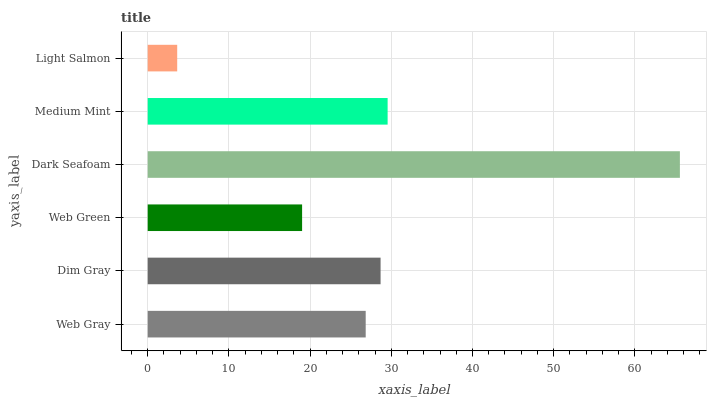Is Light Salmon the minimum?
Answer yes or no. Yes. Is Dark Seafoam the maximum?
Answer yes or no. Yes. Is Dim Gray the minimum?
Answer yes or no. No. Is Dim Gray the maximum?
Answer yes or no. No. Is Dim Gray greater than Web Gray?
Answer yes or no. Yes. Is Web Gray less than Dim Gray?
Answer yes or no. Yes. Is Web Gray greater than Dim Gray?
Answer yes or no. No. Is Dim Gray less than Web Gray?
Answer yes or no. No. Is Dim Gray the high median?
Answer yes or no. Yes. Is Web Gray the low median?
Answer yes or no. Yes. Is Light Salmon the high median?
Answer yes or no. No. Is Dim Gray the low median?
Answer yes or no. No. 